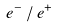<formula> <loc_0><loc_0><loc_500><loc_500>e ^ { - } \, / \, e ^ { + }</formula> 